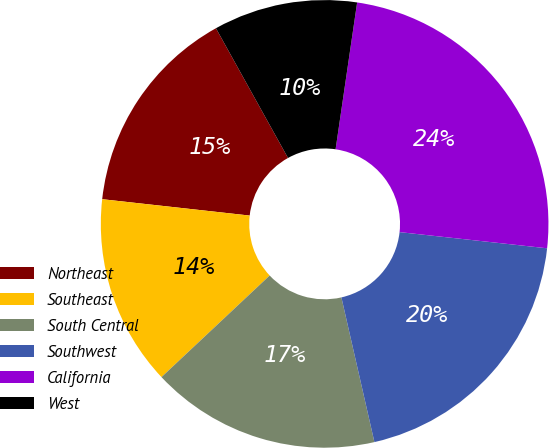Convert chart. <chart><loc_0><loc_0><loc_500><loc_500><pie_chart><fcel>Northeast<fcel>Southeast<fcel>South Central<fcel>Southwest<fcel>California<fcel>West<nl><fcel>15.17%<fcel>13.76%<fcel>16.57%<fcel>19.69%<fcel>24.42%<fcel>10.39%<nl></chart> 